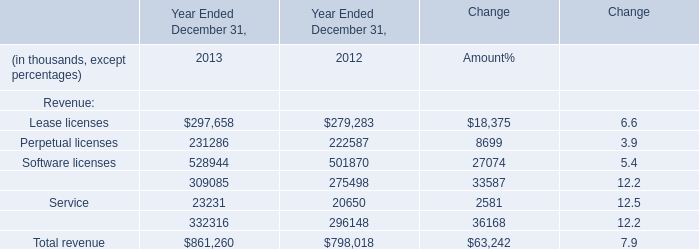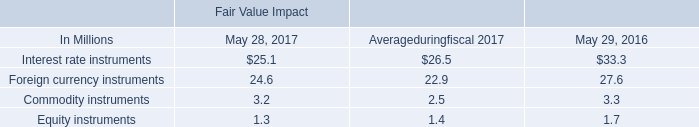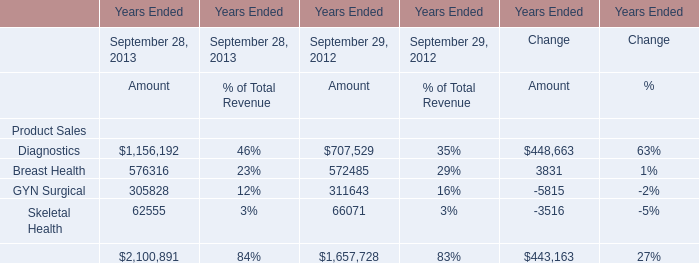What's the average of Breast Health of Years Ended September 28, 2013 Amount, and Maintenance of Year Ended December 31, 2013 ? 
Computations: ((576316.0 + 309085.0) / 2)
Answer: 442700.5. 